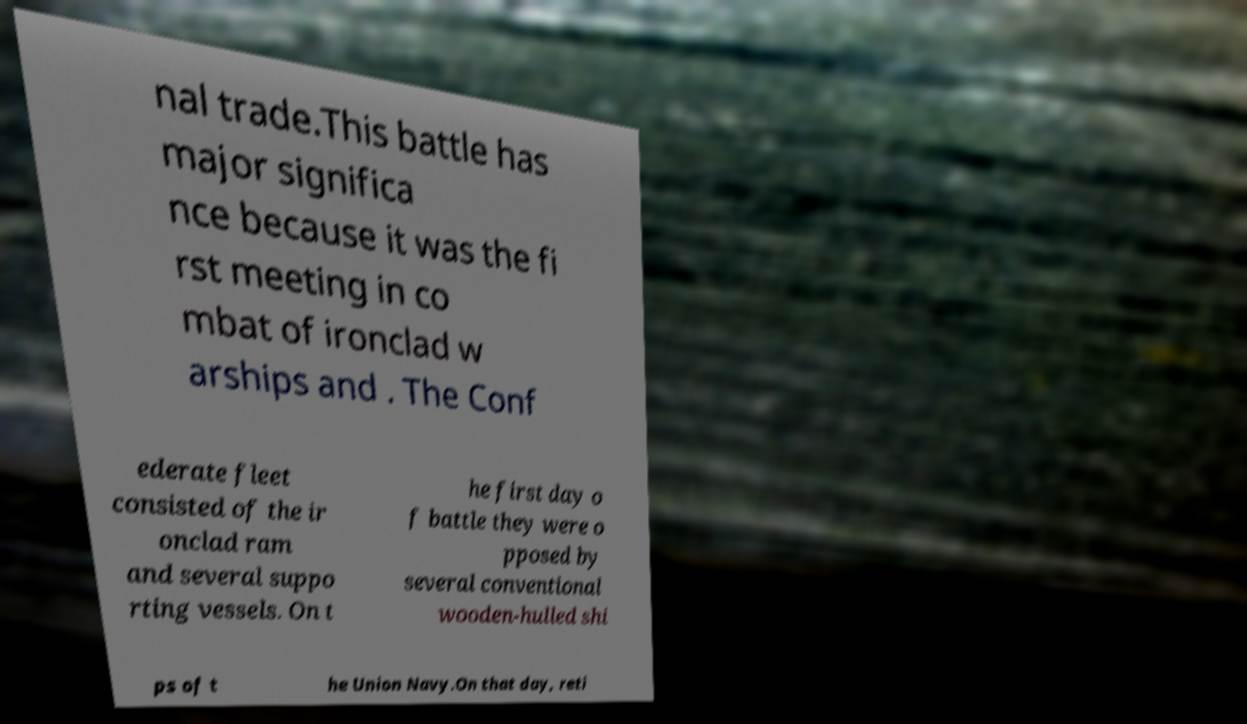Could you assist in decoding the text presented in this image and type it out clearly? nal trade.This battle has major significa nce because it was the fi rst meeting in co mbat of ironclad w arships and . The Conf ederate fleet consisted of the ir onclad ram and several suppo rting vessels. On t he first day o f battle they were o pposed by several conventional wooden-hulled shi ps of t he Union Navy.On that day, reti 